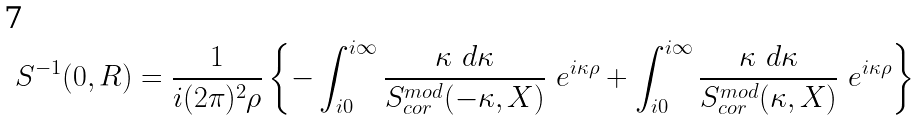Convert formula to latex. <formula><loc_0><loc_0><loc_500><loc_500>S ^ { - 1 } ( 0 , R ) = \frac { 1 } { i ( 2 \pi ) ^ { 2 } \rho } \left \{ - \int _ { i 0 } ^ { i \infty } \frac { \kappa \ d \kappa } { S _ { c o r } ^ { m o d } ( - \kappa , X ) } \ e ^ { i \kappa \rho } + \int _ { i 0 } ^ { i \infty } \frac { \kappa \ d \kappa } { S _ { c o r } ^ { m o d } ( \kappa , X ) } \ e ^ { i \kappa \rho } \right \}</formula> 